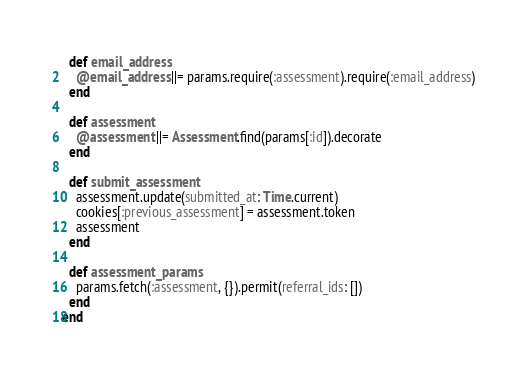<code> <loc_0><loc_0><loc_500><loc_500><_Ruby_>
  def email_address
    @email_address ||= params.require(:assessment).require(:email_address)
  end

  def assessment
    @assessment ||= Assessment.find(params[:id]).decorate
  end

  def submit_assessment
    assessment.update(submitted_at: Time.current)
    cookies[:previous_assessment] = assessment.token
    assessment
  end

  def assessment_params
    params.fetch(:assessment, {}).permit(referral_ids: [])
  end
end
</code> 